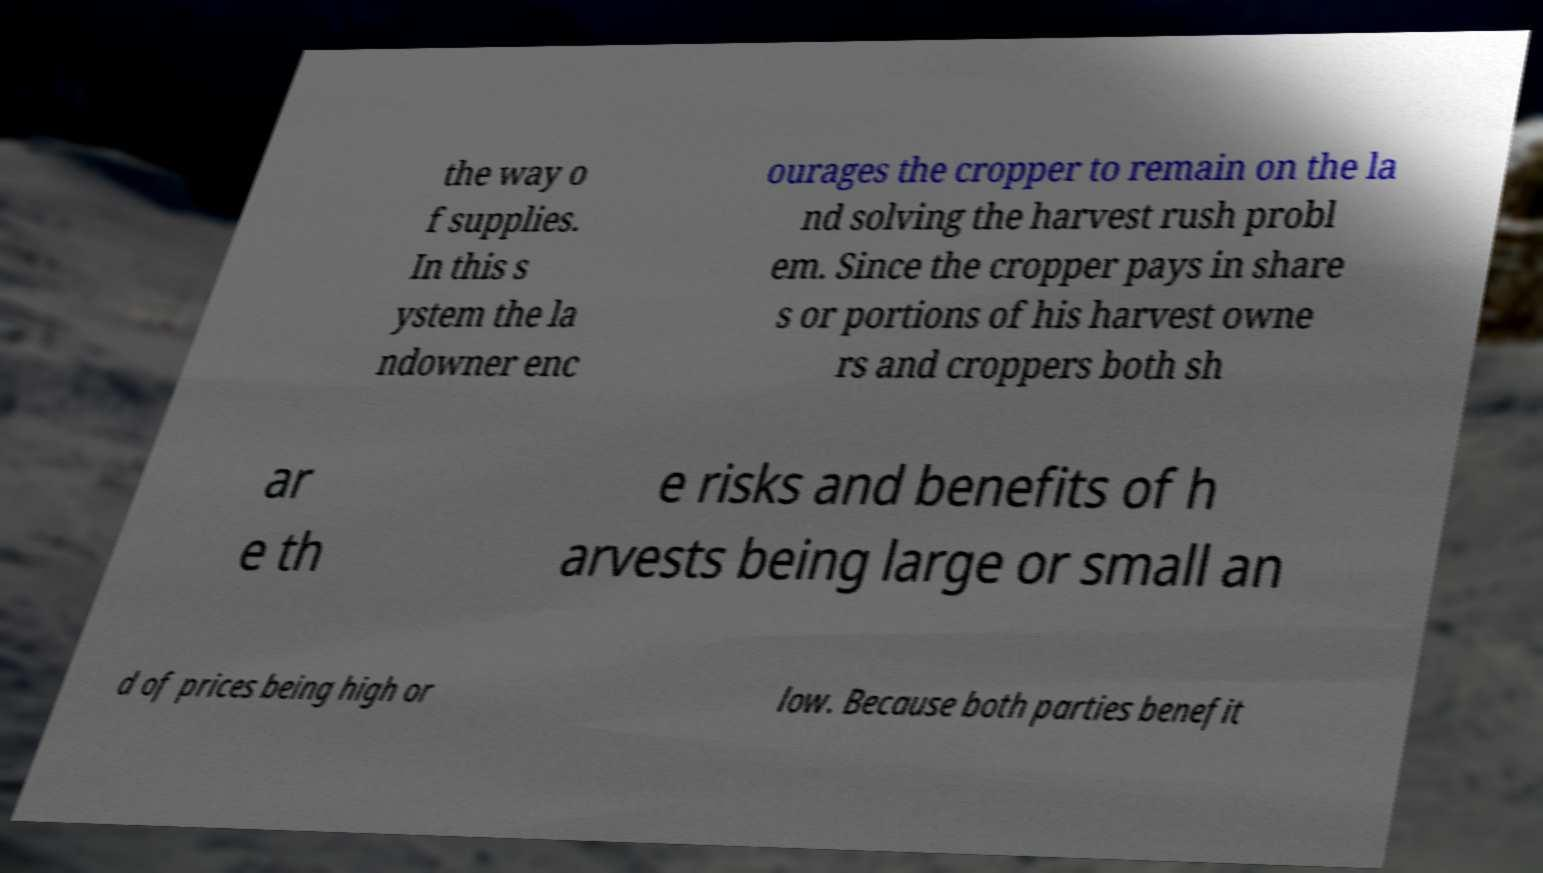There's text embedded in this image that I need extracted. Can you transcribe it verbatim? the way o f supplies. In this s ystem the la ndowner enc ourages the cropper to remain on the la nd solving the harvest rush probl em. Since the cropper pays in share s or portions of his harvest owne rs and croppers both sh ar e th e risks and benefits of h arvests being large or small an d of prices being high or low. Because both parties benefit 